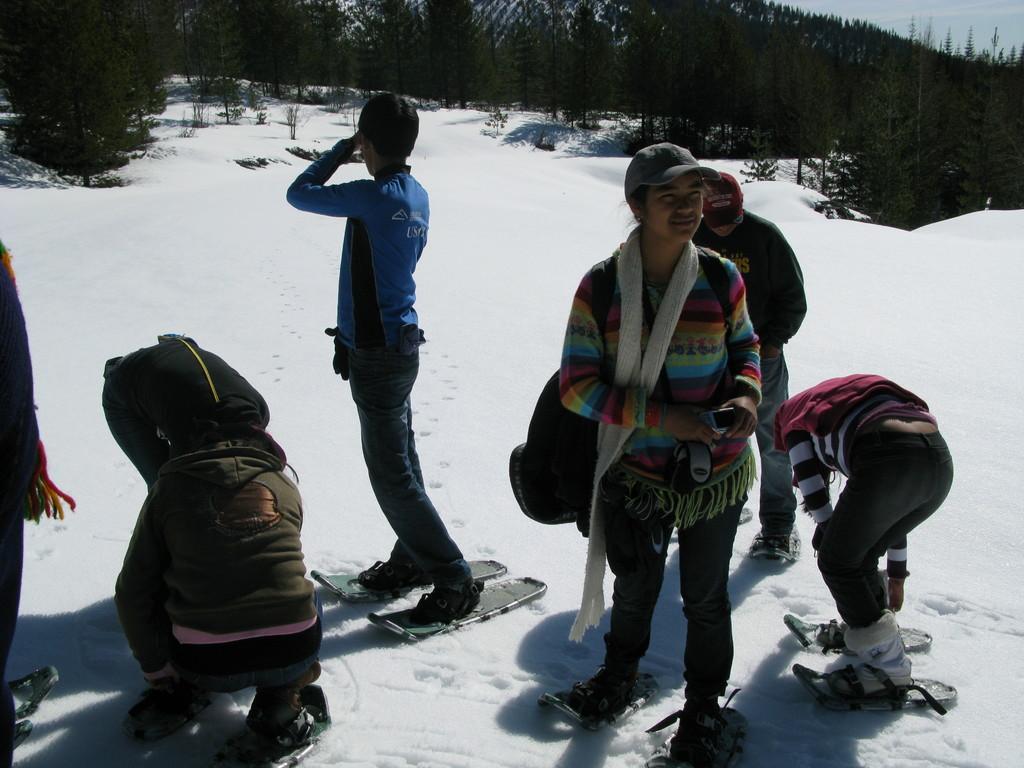Could you give a brief overview of what you see in this image? In this image we can see these people are skating on the ice using skateboards. In the background, we can see trees and the sky. 